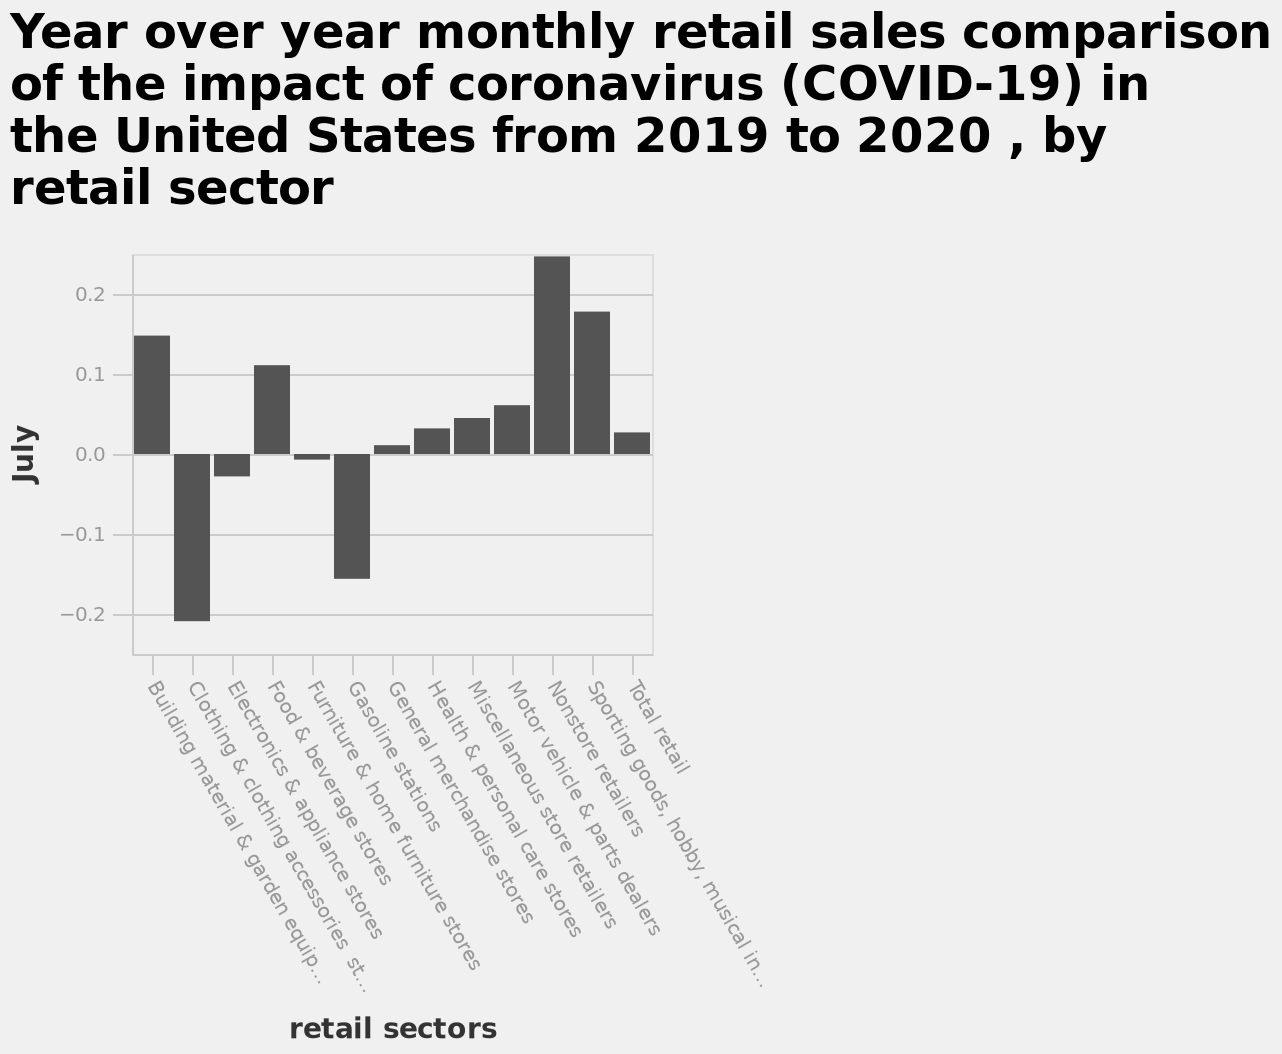<image>
What were the sectors that faced the least impact? It is not mentioned in the given description. 